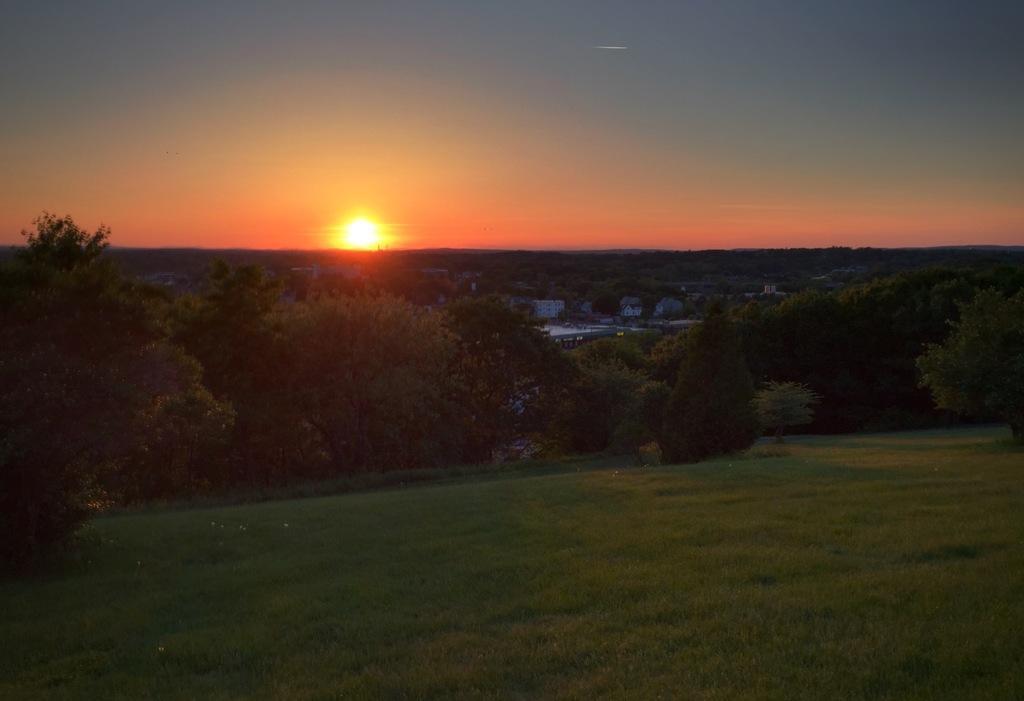Can you describe this image briefly? This is an outside view. At the bottom of the image I can see the grass on the ground. In the middle of the image there are many trees and few buildings. At the top of the image I can see the sky along with the sun. 